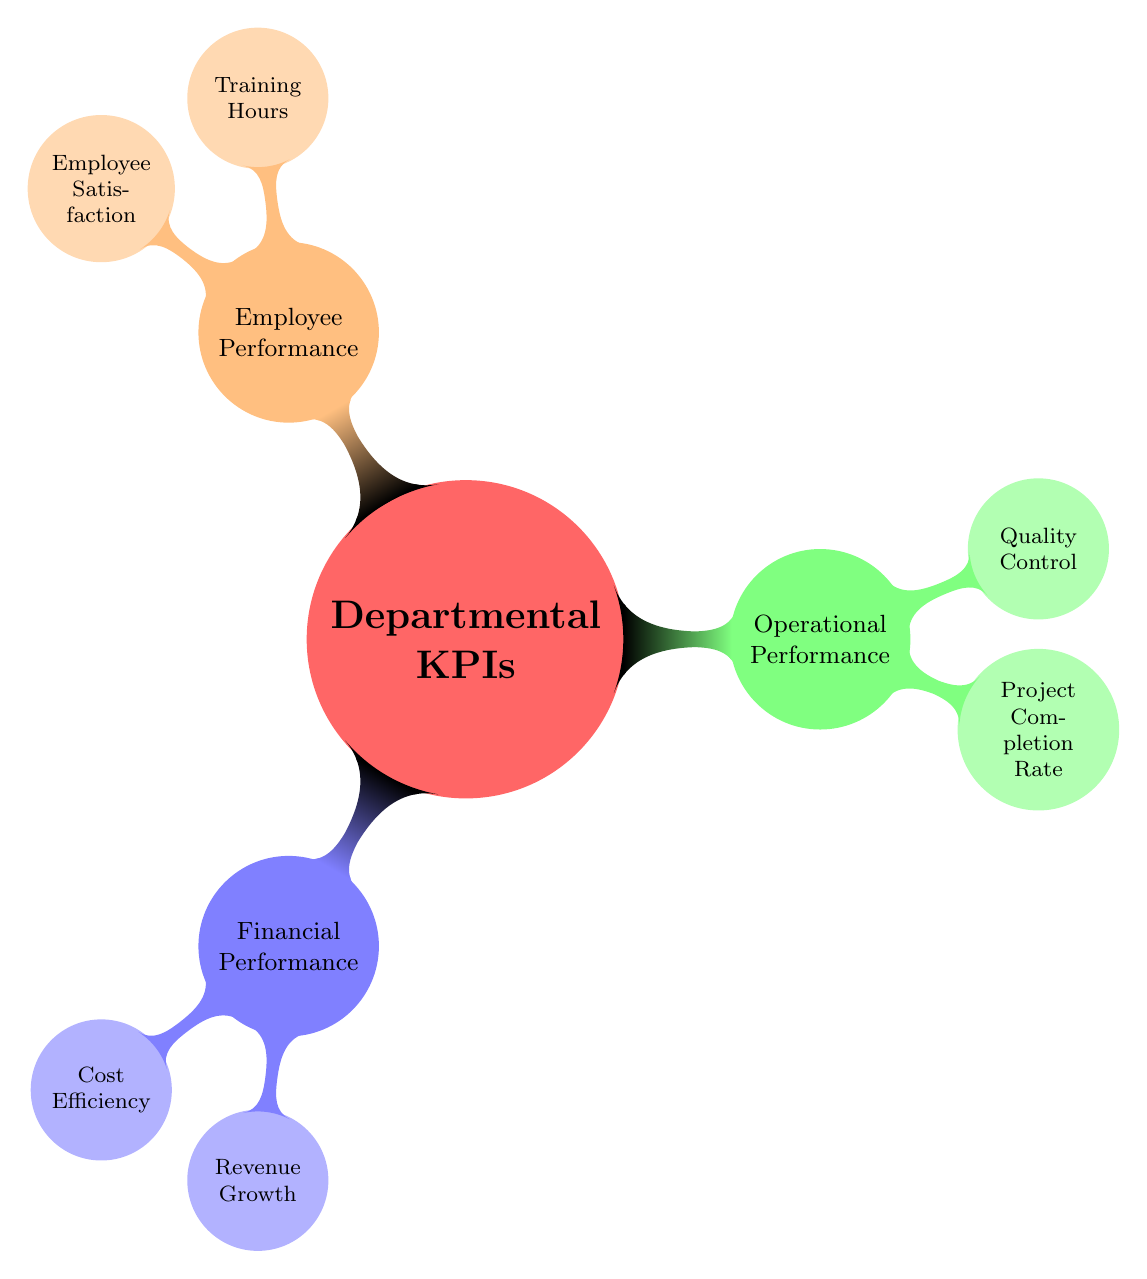What are the main categories of KPIs in the diagram? The diagram lists three main categories of KPIs under the "Departmental KPIs" node: "Financial Performance," "Operational Performance," and "Employee Performance." These three categories form the primary branches of the mindmap.
Answer: Financial Performance, Operational Performance, Employee Performance How many child nodes are under "Financial Performance"? Under the "Financial Performance" node, there are two child nodes: "Cost Efficiency" and "Revenue Growth." Therefore, we count the number of child nodes in this specific category.
Answer: 2 What is the color associated with "Employee Performance"? The "Employee Performance" node is represented in an orange color, as indicated in the diagram. This color coding helps differentiate it from the other KPI categories.
Answer: Orange Which KPI is associated with "Project Completion Rate"? The "Project Completion Rate" is a child node under "Operational Performance." To identify this, we locate the "Operational Performance" branch and look for its specific child nodes.
Answer: Project Completion Rate Which is the color associated with the "Cost Efficiency" KPI? The "Cost Efficiency" KPI is a child node of the "Financial Performance" category and is represented in a blue shade (specifically, blue!30). This color coding helps indicate its hierarchical relationship in the diagram.
Answer: Blue What are the two metrics listed under "Employee Performance"? Under "Employee Performance," there are two metrics identified: "Training Hours" and "Employee Satisfaction." We directly read these metrics from the child nodes of the Employee Performance category.
Answer: Training Hours, Employee Satisfaction How many major KPI categories are shown in the diagram? The diagram clearly shows three major KPI categories: Financial Performance, Operational Performance, and Employee Performance. By directly counting the top-level nodes, we can determine the total number of categories.
Answer: 3 Which KPI is linked to "Quality Control"? The "Quality Control" KPI is a child node under the "Operational Performance" category. To find this, we traverse to the operational performance section and identify its child metrics.
Answer: Quality Control 